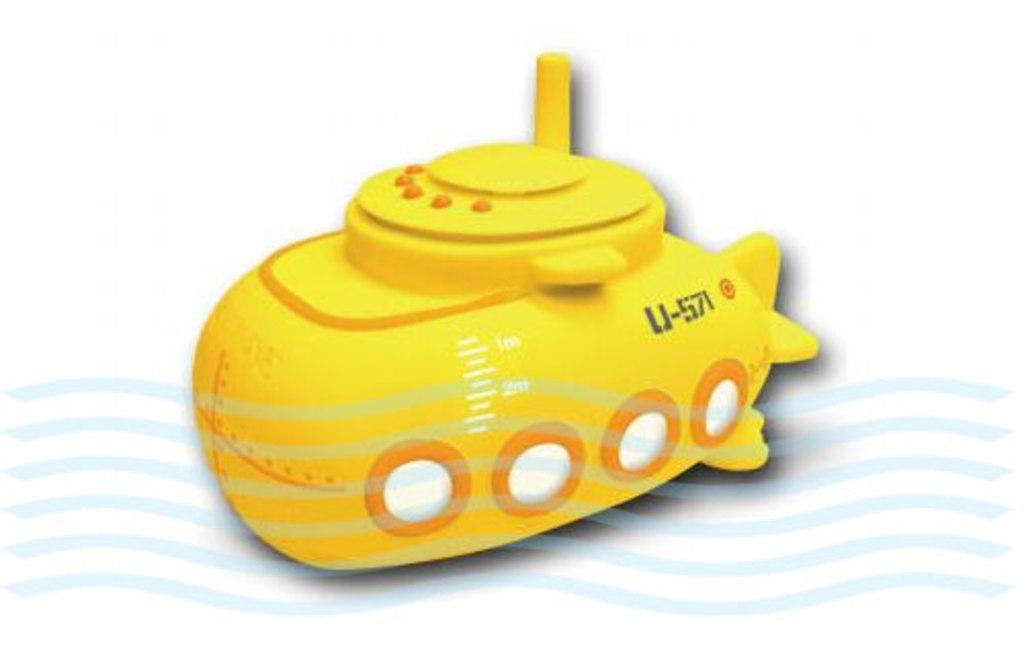What is the main subject in the center of the image? There is a toy vehicle in the center of the image. Can you describe any other features or marks in the image? There is a water mark at the bottom side of the image. What type of cream is being used to make the loaf in the image? There is no cream or loaf present in the image; it only features a toy vehicle and a water mark. 